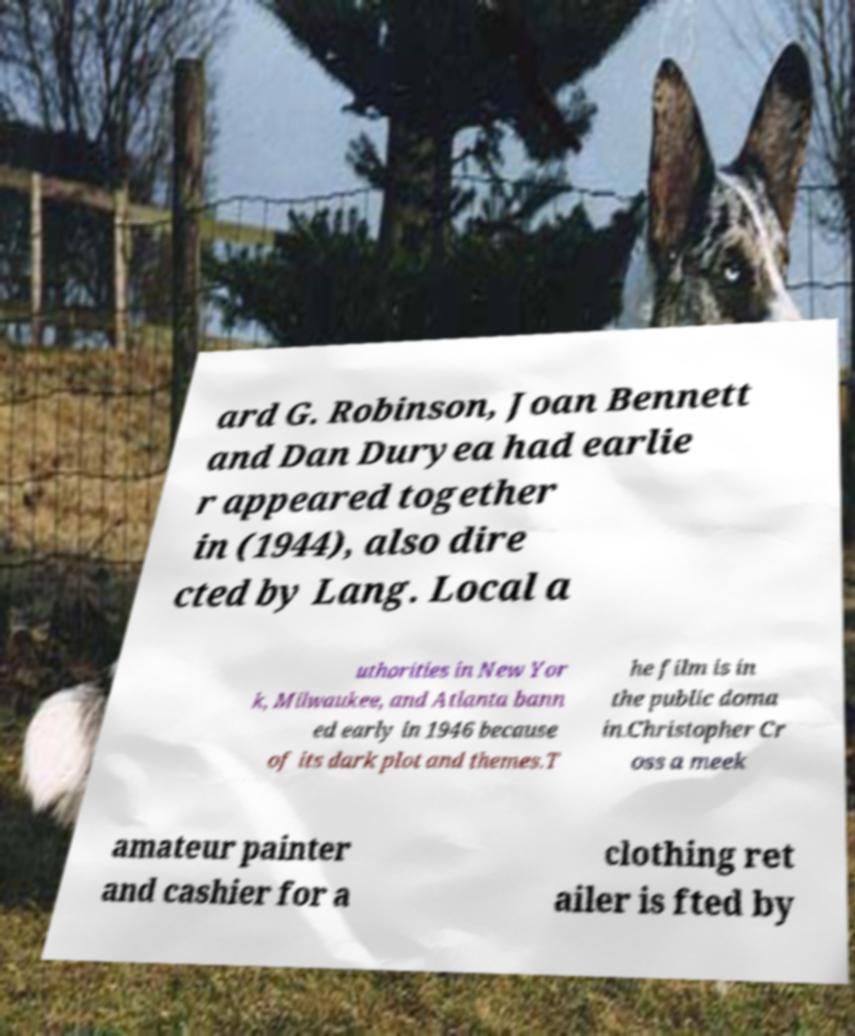Please read and relay the text visible in this image. What does it say? ard G. Robinson, Joan Bennett and Dan Duryea had earlie r appeared together in (1944), also dire cted by Lang. Local a uthorities in New Yor k, Milwaukee, and Atlanta bann ed early in 1946 because of its dark plot and themes.T he film is in the public doma in.Christopher Cr oss a meek amateur painter and cashier for a clothing ret ailer is fted by 